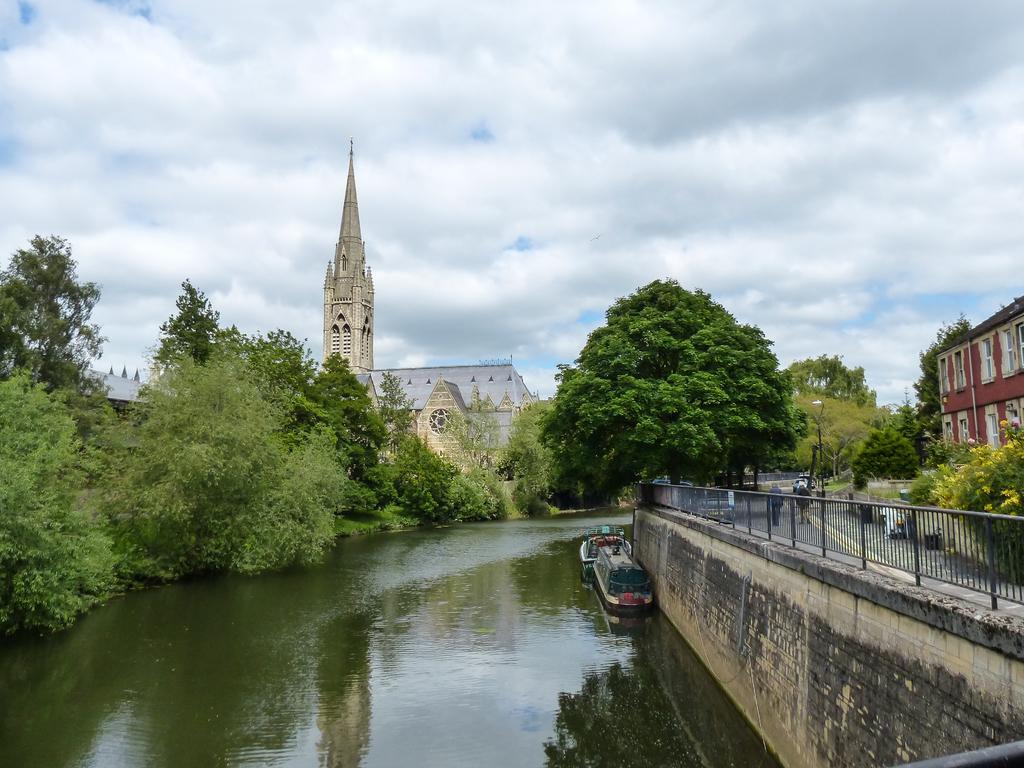Please provide a concise description of this image. In this image, I can see the buildings and trees. On the right side of the image, I can see two people on the road and iron grilles on the wall. There is a boat on the water. In the background, there is the sky. 